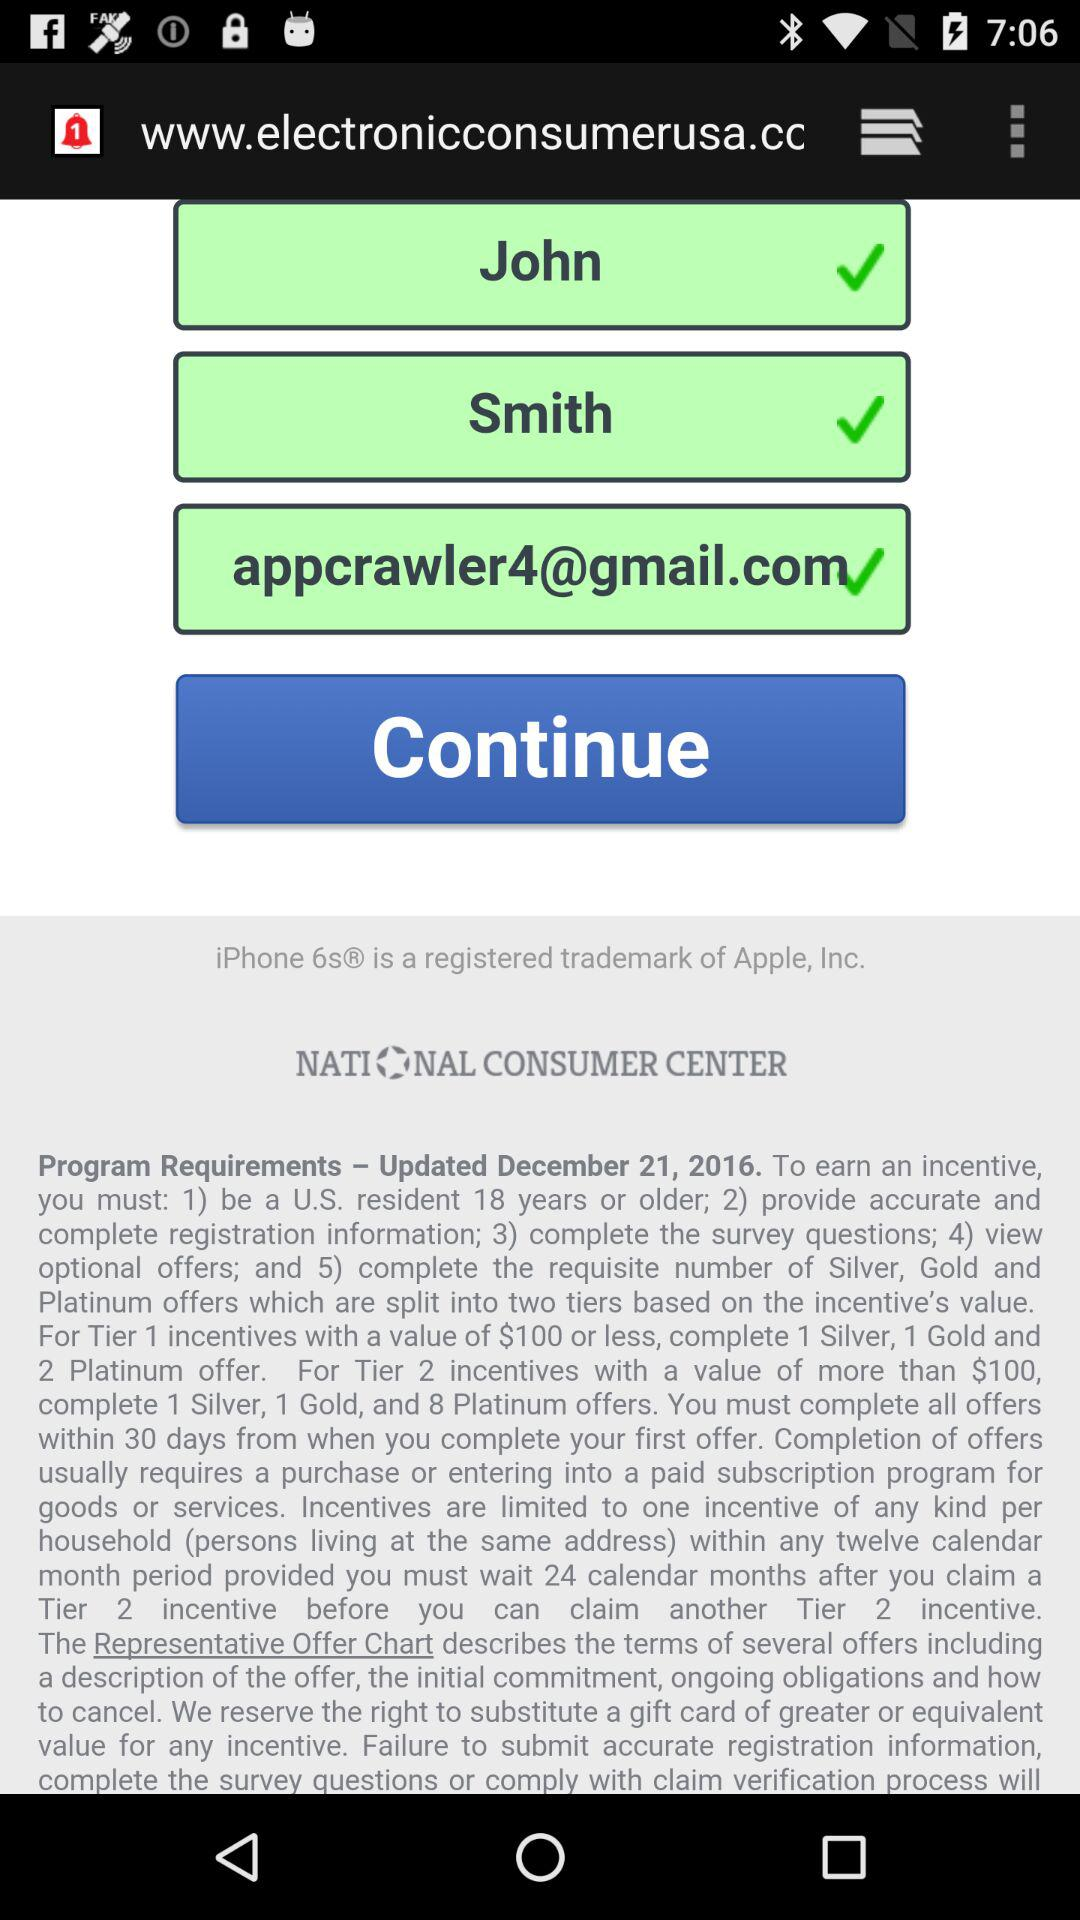What is the name of the user? The name of the user is John Smith. 